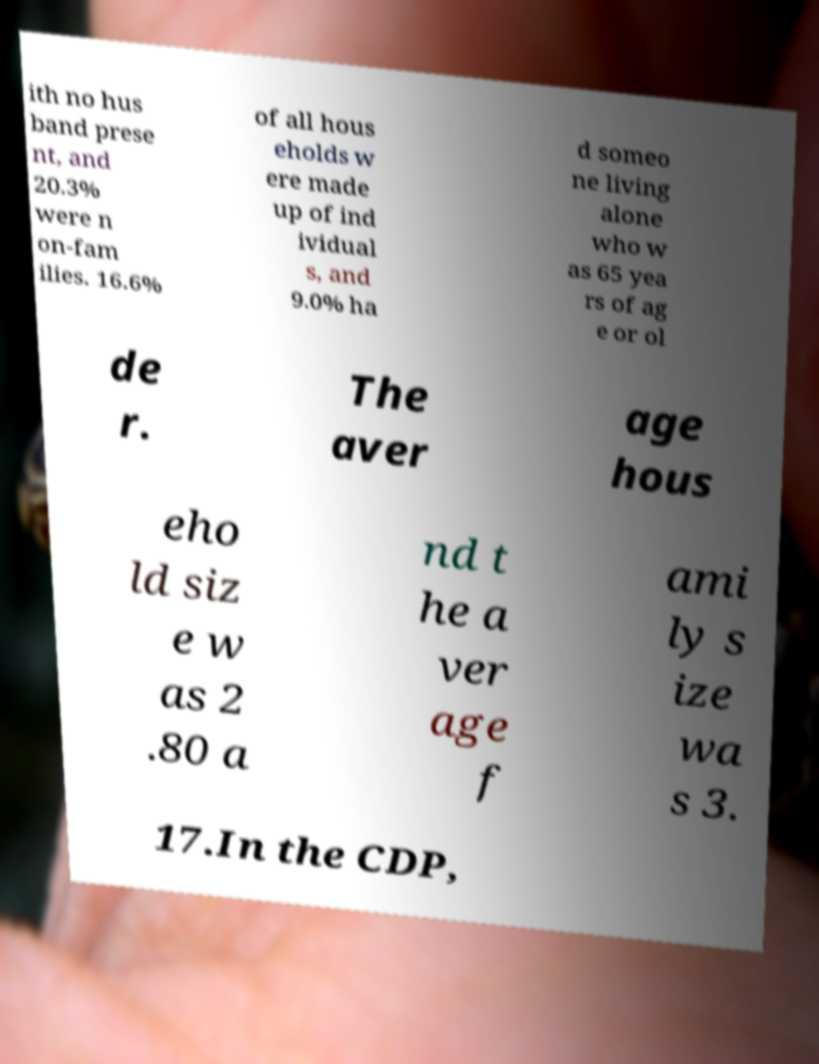Please read and relay the text visible in this image. What does it say? ith no hus band prese nt, and 20.3% were n on-fam ilies. 16.6% of all hous eholds w ere made up of ind ividual s, and 9.0% ha d someo ne living alone who w as 65 yea rs of ag e or ol de r. The aver age hous eho ld siz e w as 2 .80 a nd t he a ver age f ami ly s ize wa s 3. 17.In the CDP, 